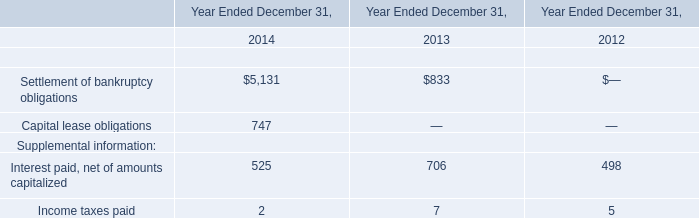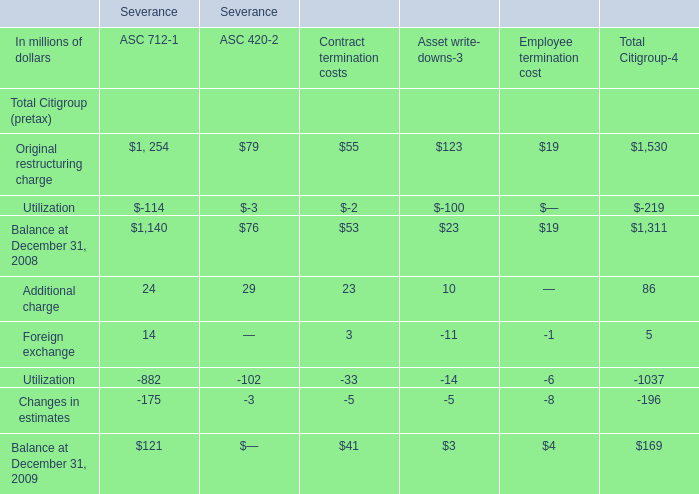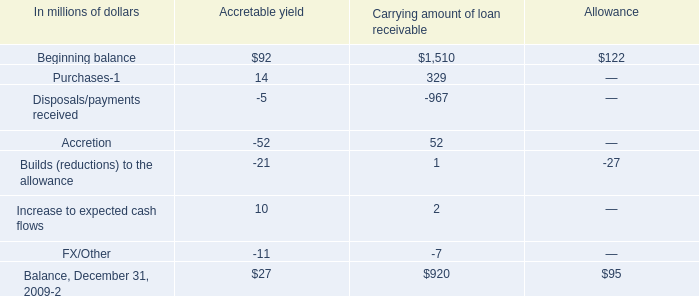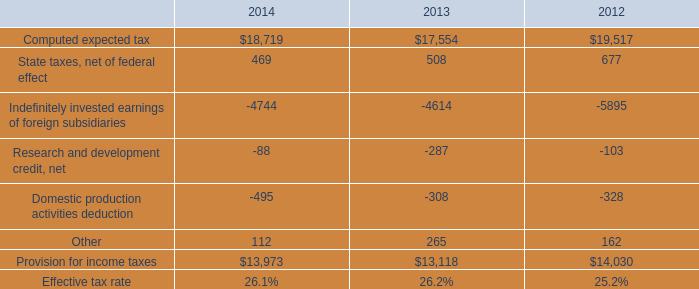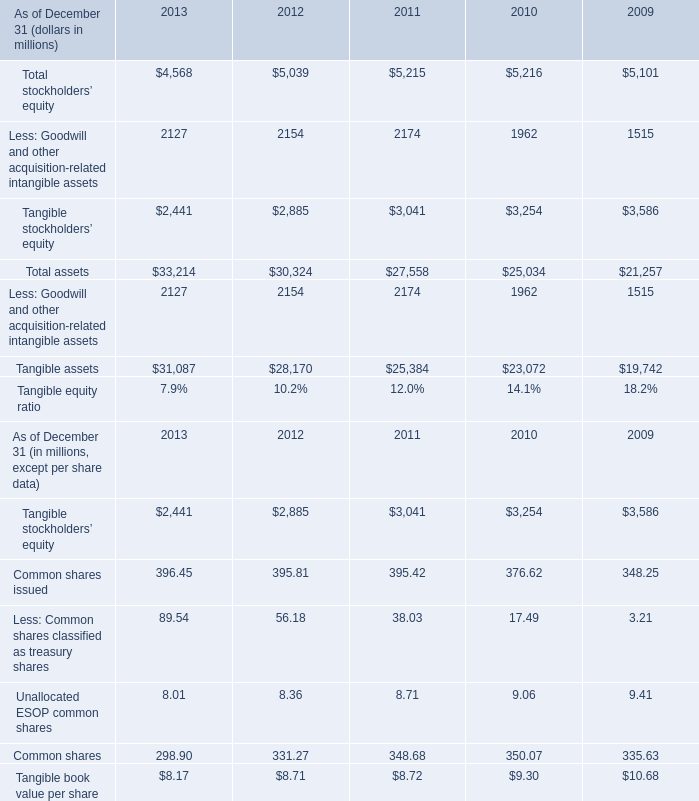What is the sum of Tangible stockholders’ equity of 2013, Provision for income taxes of 2013, and Indefinitely invested earnings of foreign subsidiaries of 2014 ? 
Computations: ((2441.0 + 13118.0) + 4744.0)
Answer: 20303.0. 